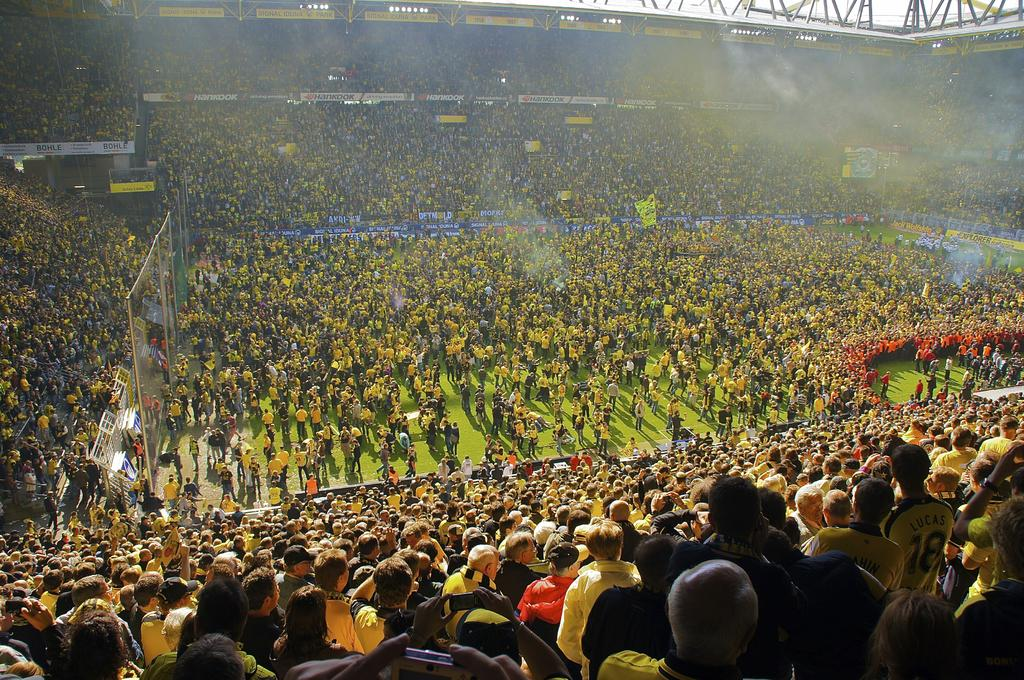What type of structure is shown in the image? The image depicts a stadium. Can you describe the people in the image? There are many people on the ground and people around the ground. What materials can be seen at the top of the image? Metal rods and boards are visible at the top of the image. Where is the door to the hill located in the image? There is no hill or door present in the image; it depicts a stadium with people and metal rods and boards at the top. 